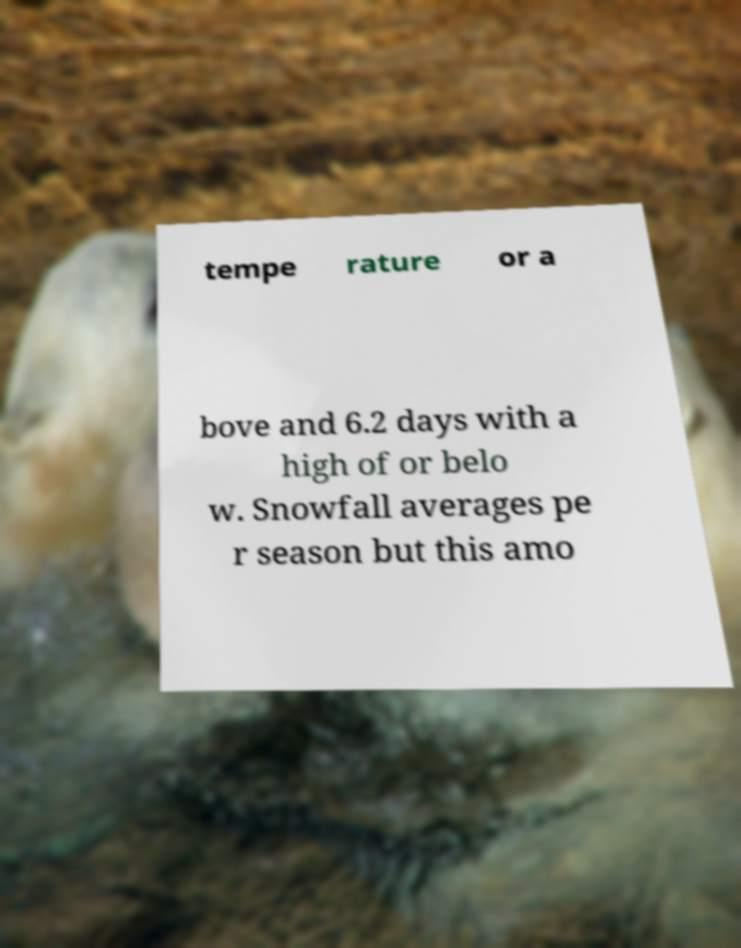I need the written content from this picture converted into text. Can you do that? tempe rature or a bove and 6.2 days with a high of or belo w. Snowfall averages pe r season but this amo 